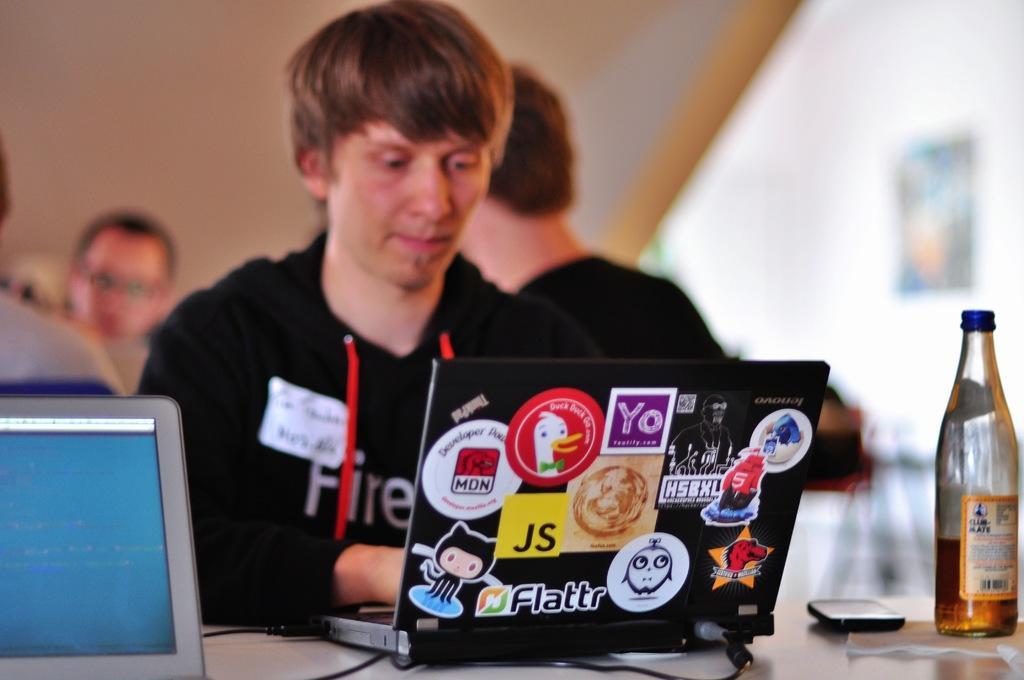Describe this image in one or two sentences. In the image we can see a man sitting wearing clothes and in front of him there is a table on the table there is a laptop, smartphone and a bottle. Behind him there are other people sitting and the background is blurred. 